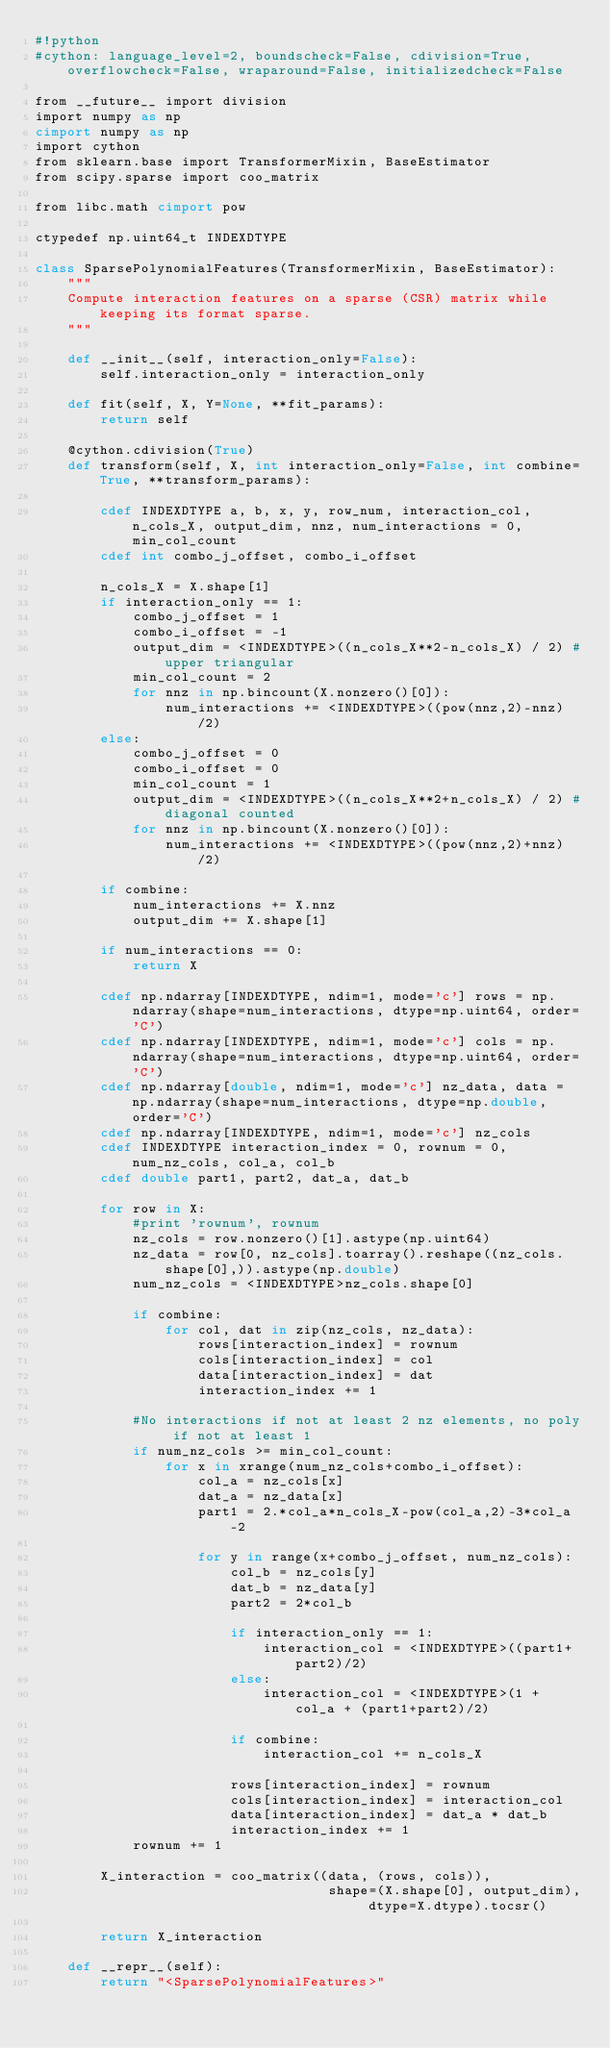<code> <loc_0><loc_0><loc_500><loc_500><_Cython_>#!python
#cython: language_level=2, boundscheck=False, cdivision=True, overflowcheck=False, wraparound=False, initializedcheck=False

from __future__ import division
import numpy as np
cimport numpy as np
import cython
from sklearn.base import TransformerMixin, BaseEstimator
from scipy.sparse import coo_matrix

from libc.math cimport pow

ctypedef np.uint64_t INDEXDTYPE

class SparsePolynomialFeatures(TransformerMixin, BaseEstimator):
    """
    Compute interaction features on a sparse (CSR) matrix while keeping its format sparse.
    """
    
    def __init__(self, interaction_only=False):
        self.interaction_only = interaction_only
    
    def fit(self, X, Y=None, **fit_params):
        return self
    
    @cython.cdivision(True)
    def transform(self, X, int interaction_only=False, int combine=True, **transform_params):
                                                        
        cdef INDEXDTYPE a, b, x, y, row_num, interaction_col, n_cols_X, output_dim, nnz, num_interactions = 0, min_col_count
        cdef int combo_j_offset, combo_i_offset
        
        n_cols_X = X.shape[1]
        if interaction_only == 1:
            combo_j_offset = 1
            combo_i_offset = -1
            output_dim = <INDEXDTYPE>((n_cols_X**2-n_cols_X) / 2) #upper triangular
            min_col_count = 2
            for nnz in np.bincount(X.nonzero()[0]):
                num_interactions += <INDEXDTYPE>((pow(nnz,2)-nnz)/2)
        else:
            combo_j_offset = 0
            combo_i_offset = 0
            min_col_count = 1
            output_dim = <INDEXDTYPE>((n_cols_X**2+n_cols_X) / 2) #diagonal counted
            for nnz in np.bincount(X.nonzero()[0]):
                num_interactions += <INDEXDTYPE>((pow(nnz,2)+nnz)/2)
        
        if combine:
            num_interactions += X.nnz
            output_dim += X.shape[1]
            
        if num_interactions == 0:
            return X
        
        cdef np.ndarray[INDEXDTYPE, ndim=1, mode='c'] rows = np.ndarray(shape=num_interactions, dtype=np.uint64, order='C')
        cdef np.ndarray[INDEXDTYPE, ndim=1, mode='c'] cols = np.ndarray(shape=num_interactions, dtype=np.uint64, order='C')
        cdef np.ndarray[double, ndim=1, mode='c'] nz_data, data = np.ndarray(shape=num_interactions, dtype=np.double, order='C')
        cdef np.ndarray[INDEXDTYPE, ndim=1, mode='c'] nz_cols
        cdef INDEXDTYPE interaction_index = 0, rownum = 0, num_nz_cols, col_a, col_b
        cdef double part1, part2, dat_a, dat_b
        
        for row in X:
            #print 'rownum', rownum
            nz_cols = row.nonzero()[1].astype(np.uint64)
            nz_data = row[0, nz_cols].toarray().reshape((nz_cols.shape[0],)).astype(np.double)
            num_nz_cols = <INDEXDTYPE>nz_cols.shape[0]
            
            if combine:
                for col, dat in zip(nz_cols, nz_data):                
                    rows[interaction_index] = rownum
                    cols[interaction_index] = col
                    data[interaction_index] = dat
                    interaction_index += 1
            
            #No interactions if not at least 2 nz elements, no poly if not at least 1
            if num_nz_cols >= min_col_count:
                for x in xrange(num_nz_cols+combo_i_offset):
                    col_a = nz_cols[x]
                    dat_a = nz_data[x]
                    part1 = 2.*col_a*n_cols_X-pow(col_a,2)-3*col_a-2
                        
                    for y in range(x+combo_j_offset, num_nz_cols):
                        col_b = nz_cols[y]
                        dat_b = nz_data[y]
                        part2 = 2*col_b
                        
                        if interaction_only == 1:
                            interaction_col = <INDEXDTYPE>((part1+part2)/2)
                        else:
                            interaction_col = <INDEXDTYPE>(1 + col_a + (part1+part2)/2)
                        
                        if combine:
                            interaction_col += n_cols_X
                            
                        rows[interaction_index] = rownum
                        cols[interaction_index] = interaction_col
                        data[interaction_index] = dat_a * dat_b
                        interaction_index += 1
            rownum += 1
        
        X_interaction = coo_matrix((data, (rows, cols)), 
                                    shape=(X.shape[0], output_dim), dtype=X.dtype).tocsr()
        
        return X_interaction
    
    def __repr__(self):
        return "<SparsePolynomialFeatures>"
</code> 